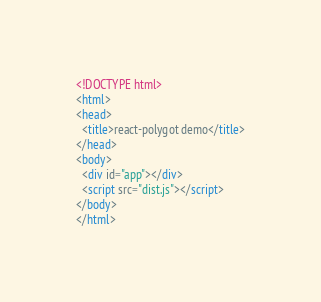<code> <loc_0><loc_0><loc_500><loc_500><_HTML_><!DOCTYPE html>
<html>
<head>
  <title>react-polygot demo</title>
</head>
<body>
  <div id="app"></div>
  <script src="dist.js"></script>
</body>
</html>
</code> 